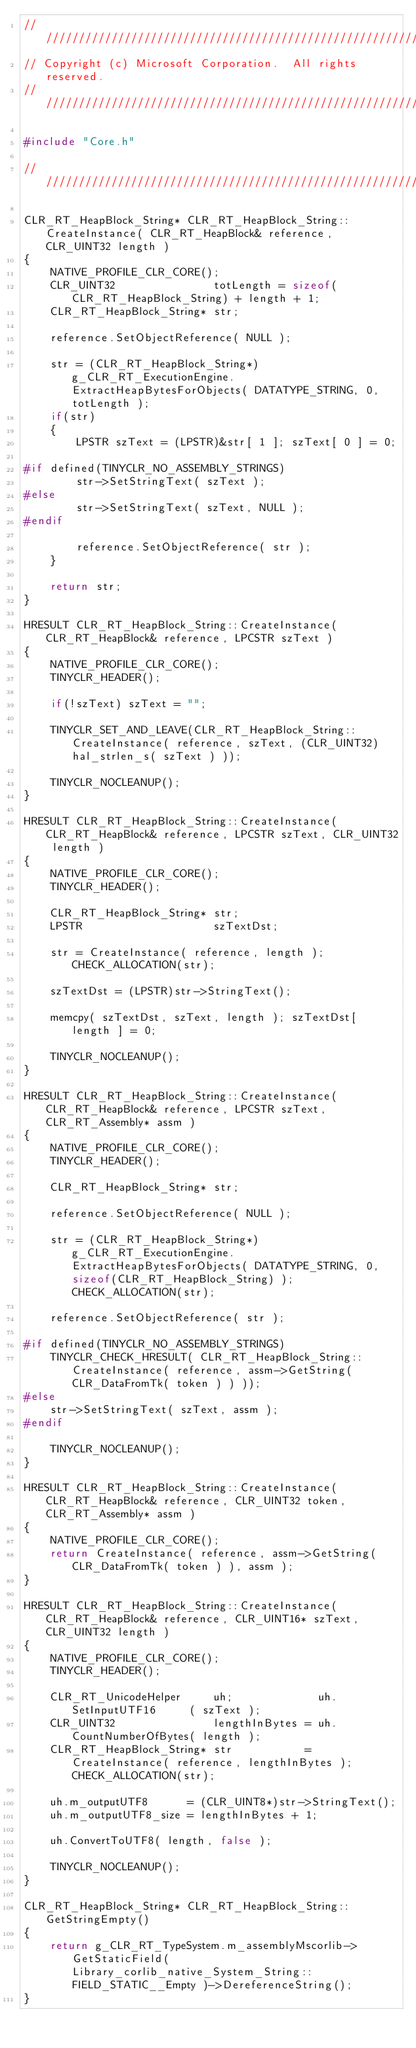Convert code to text. <code><loc_0><loc_0><loc_500><loc_500><_C++_>////////////////////////////////////////////////////////////////////////////////////////////////////////////////////////////////////////////////////////////////////////////////////////////////////////
// Copyright (c) Microsoft Corporation.  All rights reserved.
////////////////////////////////////////////////////////////////////////////////////////////////////////////////////////////////////////////////////////////////////////////////////////////////////////

#include "Core.h"

////////////////////////////////////////////////////////////////////////////////////////////////////

CLR_RT_HeapBlock_String* CLR_RT_HeapBlock_String::CreateInstance( CLR_RT_HeapBlock& reference, CLR_UINT32 length )
{
    NATIVE_PROFILE_CLR_CORE();
    CLR_UINT32               totLength = sizeof(CLR_RT_HeapBlock_String) + length + 1;
    CLR_RT_HeapBlock_String* str;

    reference.SetObjectReference( NULL );

    str = (CLR_RT_HeapBlock_String*)g_CLR_RT_ExecutionEngine.ExtractHeapBytesForObjects( DATATYPE_STRING, 0, totLength );
    if(str)
    {
        LPSTR szText = (LPSTR)&str[ 1 ]; szText[ 0 ] = 0;

#if defined(TINYCLR_NO_ASSEMBLY_STRINGS)
        str->SetStringText( szText );
#else
        str->SetStringText( szText, NULL );
#endif     

        reference.SetObjectReference( str );
    }

    return str;
}

HRESULT CLR_RT_HeapBlock_String::CreateInstance( CLR_RT_HeapBlock& reference, LPCSTR szText )
{
    NATIVE_PROFILE_CLR_CORE();
    TINYCLR_HEADER();

    if(!szText) szText = "";

    TINYCLR_SET_AND_LEAVE(CLR_RT_HeapBlock_String::CreateInstance( reference, szText, (CLR_UINT32)hal_strlen_s( szText ) ));

    TINYCLR_NOCLEANUP();
}

HRESULT CLR_RT_HeapBlock_String::CreateInstance( CLR_RT_HeapBlock& reference, LPCSTR szText, CLR_UINT32 length )
{
    NATIVE_PROFILE_CLR_CORE();
    TINYCLR_HEADER();

    CLR_RT_HeapBlock_String* str;
    LPSTR                    szTextDst;

    str = CreateInstance( reference, length ); CHECK_ALLOCATION(str);

    szTextDst = (LPSTR)str->StringText();

    memcpy( szTextDst, szText, length ); szTextDst[ length ] = 0;

    TINYCLR_NOCLEANUP();
}

HRESULT CLR_RT_HeapBlock_String::CreateInstance( CLR_RT_HeapBlock& reference, LPCSTR szText, CLR_RT_Assembly* assm )
{        
    NATIVE_PROFILE_CLR_CORE();
    TINYCLR_HEADER();

    CLR_RT_HeapBlock_String* str;

    reference.SetObjectReference( NULL );

    str = (CLR_RT_HeapBlock_String*)g_CLR_RT_ExecutionEngine.ExtractHeapBytesForObjects( DATATYPE_STRING, 0, sizeof(CLR_RT_HeapBlock_String) ); CHECK_ALLOCATION(str);

    reference.SetObjectReference( str );

#if defined(TINYCLR_NO_ASSEMBLY_STRINGS)            
    TINYCLR_CHECK_HRESULT( CLR_RT_HeapBlock_String::CreateInstance( reference, assm->GetString( CLR_DataFromTk( token ) ) ));    
#else
    str->SetStringText( szText, assm );
#endif

    TINYCLR_NOCLEANUP();
}

HRESULT CLR_RT_HeapBlock_String::CreateInstance( CLR_RT_HeapBlock& reference, CLR_UINT32 token, CLR_RT_Assembly* assm )
{
    NATIVE_PROFILE_CLR_CORE();
    return CreateInstance( reference, assm->GetString( CLR_DataFromTk( token ) ), assm );
}

HRESULT CLR_RT_HeapBlock_String::CreateInstance( CLR_RT_HeapBlock& reference, CLR_UINT16* szText, CLR_UINT32 length )
{
    NATIVE_PROFILE_CLR_CORE();
    TINYCLR_HEADER();

    CLR_RT_UnicodeHelper     uh;             uh.SetInputUTF16     ( szText );
    CLR_UINT32               lengthInBytes = uh.CountNumberOfBytes( length );
    CLR_RT_HeapBlock_String* str           = CreateInstance( reference, lengthInBytes ); CHECK_ALLOCATION(str);
    
    uh.m_outputUTF8      = (CLR_UINT8*)str->StringText();
    uh.m_outputUTF8_size = lengthInBytes + 1;

    uh.ConvertToUTF8( length, false );

    TINYCLR_NOCLEANUP();
}

CLR_RT_HeapBlock_String* CLR_RT_HeapBlock_String::GetStringEmpty()
{
    return g_CLR_RT_TypeSystem.m_assemblyMscorlib->GetStaticField( Library_corlib_native_System_String::FIELD_STATIC__Empty )->DereferenceString(); 
}
</code> 